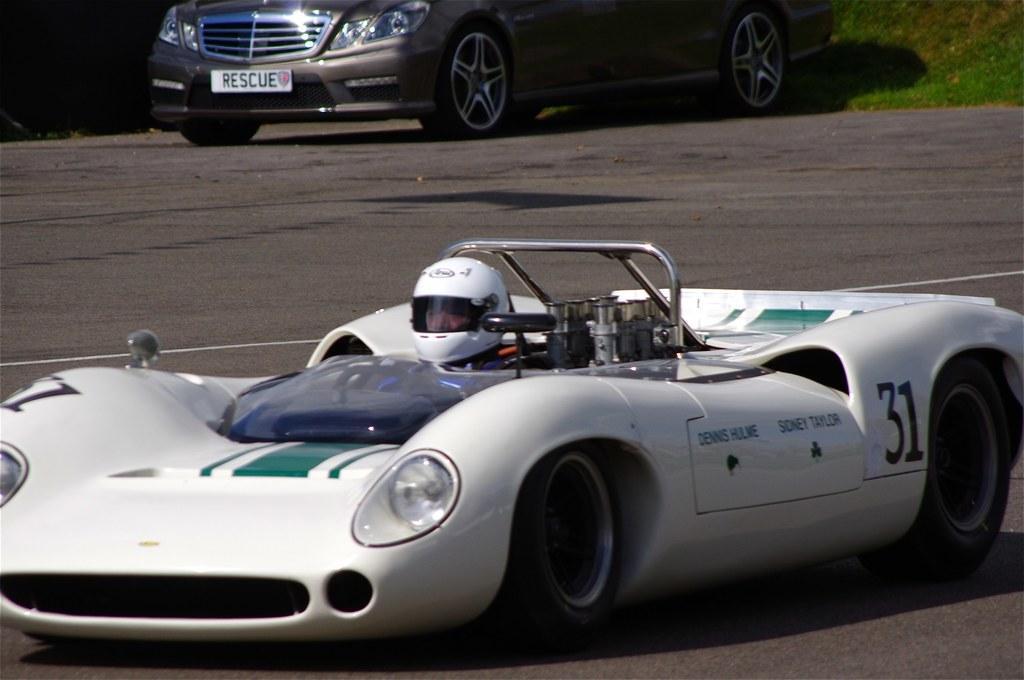Please provide a concise description of this image. In this picture there is a person riding a car and there is another car here in the backdrop. 